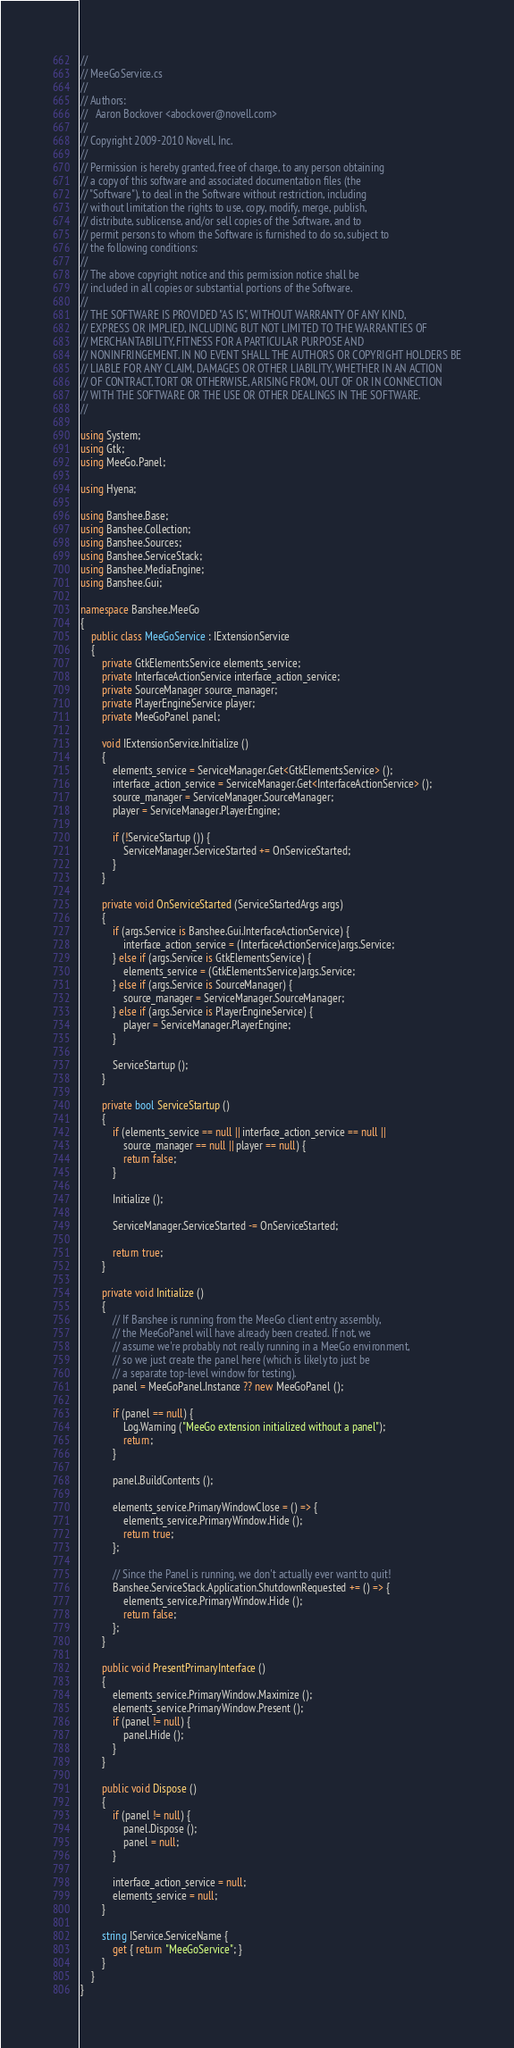Convert code to text. <code><loc_0><loc_0><loc_500><loc_500><_C#_>//
// MeeGoService.cs
//
// Authors:
//   Aaron Bockover <abockover@novell.com>
//
// Copyright 2009-2010 Novell, Inc.
//
// Permission is hereby granted, free of charge, to any person obtaining
// a copy of this software and associated documentation files (the
// "Software"), to deal in the Software without restriction, including
// without limitation the rights to use, copy, modify, merge, publish,
// distribute, sublicense, and/or sell copies of the Software, and to
// permit persons to whom the Software is furnished to do so, subject to
// the following conditions:
//
// The above copyright notice and this permission notice shall be
// included in all copies or substantial portions of the Software.
//
// THE SOFTWARE IS PROVIDED "AS IS", WITHOUT WARRANTY OF ANY KIND,
// EXPRESS OR IMPLIED, INCLUDING BUT NOT LIMITED TO THE WARRANTIES OF
// MERCHANTABILITY, FITNESS FOR A PARTICULAR PURPOSE AND
// NONINFRINGEMENT. IN NO EVENT SHALL THE AUTHORS OR COPYRIGHT HOLDERS BE
// LIABLE FOR ANY CLAIM, DAMAGES OR OTHER LIABILITY, WHETHER IN AN ACTION
// OF CONTRACT, TORT OR OTHERWISE, ARISING FROM, OUT OF OR IN CONNECTION
// WITH THE SOFTWARE OR THE USE OR OTHER DEALINGS IN THE SOFTWARE.
//

using System;
using Gtk;
using MeeGo.Panel;

using Hyena;

using Banshee.Base;
using Banshee.Collection;
using Banshee.Sources;
using Banshee.ServiceStack;
using Banshee.MediaEngine;
using Banshee.Gui;

namespace Banshee.MeeGo
{
    public class MeeGoService : IExtensionService
    {
        private GtkElementsService elements_service;
        private InterfaceActionService interface_action_service;
        private SourceManager source_manager;
        private PlayerEngineService player;
        private MeeGoPanel panel;

        void IExtensionService.Initialize ()
        {
            elements_service = ServiceManager.Get<GtkElementsService> ();
            interface_action_service = ServiceManager.Get<InterfaceActionService> ();
            source_manager = ServiceManager.SourceManager;
            player = ServiceManager.PlayerEngine;

            if (!ServiceStartup ()) {
                ServiceManager.ServiceStarted += OnServiceStarted;
            }
        }

        private void OnServiceStarted (ServiceStartedArgs args)
        {
            if (args.Service is Banshee.Gui.InterfaceActionService) {
                interface_action_service = (InterfaceActionService)args.Service;
            } else if (args.Service is GtkElementsService) {
                elements_service = (GtkElementsService)args.Service;
            } else if (args.Service is SourceManager) {
                source_manager = ServiceManager.SourceManager;
            } else if (args.Service is PlayerEngineService) {
                player = ServiceManager.PlayerEngine;
            }

            ServiceStartup ();
        }

        private bool ServiceStartup ()
        {
            if (elements_service == null || interface_action_service == null ||
                source_manager == null || player == null) {
                return false;
            }

            Initialize ();

            ServiceManager.ServiceStarted -= OnServiceStarted;

            return true;
        }

        private void Initialize ()
        {
            // If Banshee is running from the MeeGo client entry assembly,
            // the MeeGoPanel will have already been created. If not, we
            // assume we're probably not really running in a MeeGo environment,
            // so we just create the panel here (which is likely to just be
            // a separate top-level window for testing).
            panel = MeeGoPanel.Instance ?? new MeeGoPanel ();

            if (panel == null) {
                Log.Warning ("MeeGo extension initialized without a panel");
                return;
            }

            panel.BuildContents ();

            elements_service.PrimaryWindowClose = () => {
                elements_service.PrimaryWindow.Hide ();
                return true;
            };

            // Since the Panel is running, we don't actually ever want to quit!
            Banshee.ServiceStack.Application.ShutdownRequested += () => {
                elements_service.PrimaryWindow.Hide ();
                return false;
            };
        }

        public void PresentPrimaryInterface ()
        {
            elements_service.PrimaryWindow.Maximize ();
            elements_service.PrimaryWindow.Present ();
            if (panel != null) {
                panel.Hide ();
            }
        }

        public void Dispose ()
        {
            if (panel != null) {
                panel.Dispose ();
                panel = null;
            }

            interface_action_service = null;
            elements_service = null;
        }

        string IService.ServiceName {
            get { return "MeeGoService"; }
        }
    }
}
</code> 